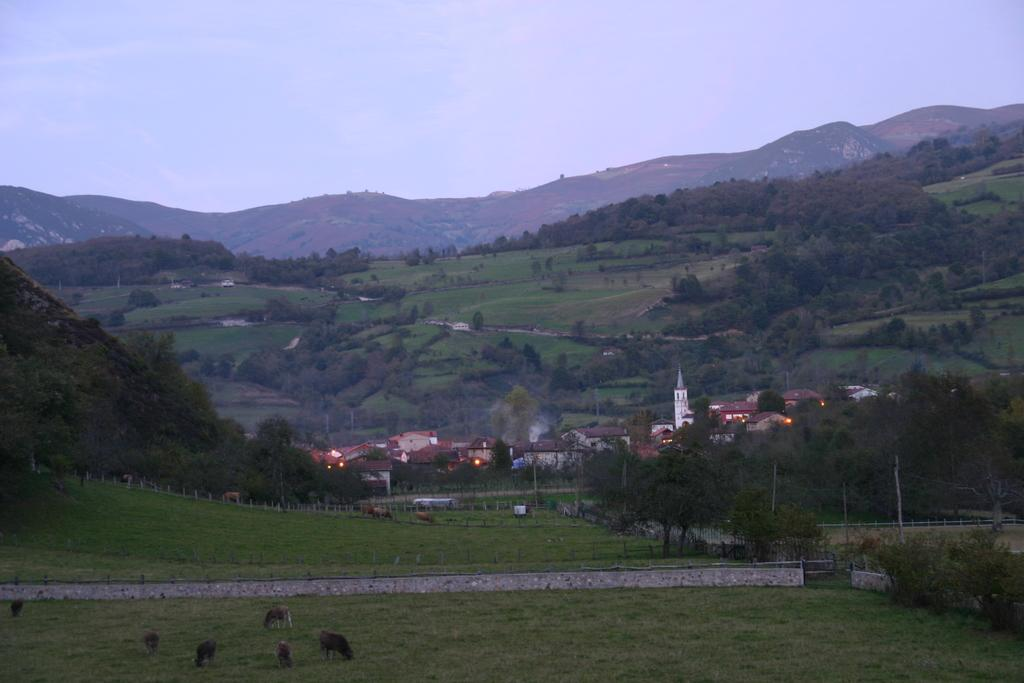What type of natural landscape can be seen in the image? There are mountains, trees, and grass visible in the image. What type of structures can be seen in the image? Houses and a bridge are visible in the image. What type of animals are present in the image? Animals are present in the image. What part of the natural environment is visible in the image? The sky is visible in the image. Where can the honey be found in the image? There is no honey present in the image. What type of flame can be seen coming from the bridge in the image? There is no flame present in the image, and the bridge is not on fire. 